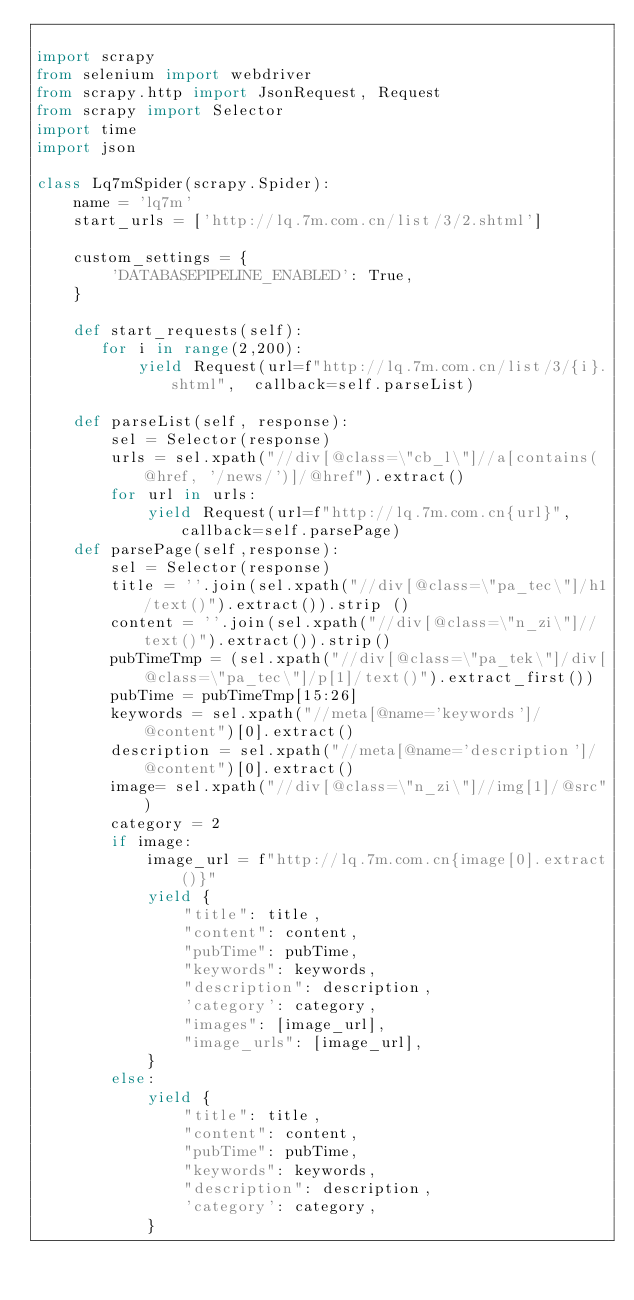<code> <loc_0><loc_0><loc_500><loc_500><_Python_>
import scrapy
from selenium import webdriver
from scrapy.http import JsonRequest, Request
from scrapy import Selector
import time
import json

class Lq7mSpider(scrapy.Spider):
    name = 'lq7m'
    start_urls = ['http://lq.7m.com.cn/list/3/2.shtml']

    custom_settings = {
        'DATABASEPIPELINE_ENABLED': True,
    }

    def start_requests(self):
       for i in range(2,200):
           yield Request(url=f"http://lq.7m.com.cn/list/3/{i}.shtml",  callback=self.parseList)

    def parseList(self, response):
        sel = Selector(response)
        urls = sel.xpath("//div[@class=\"cb_l\"]//a[contains(@href, '/news/')]/@href").extract()
        for url in urls:
            yield Request(url=f"http://lq.7m.com.cn{url}",callback=self.parsePage)
    def parsePage(self,response):
        sel = Selector(response)
        title = ''.join(sel.xpath("//div[@class=\"pa_tec\"]/h1/text()").extract()).strip ()
        content = ''.join(sel.xpath("//div[@class=\"n_zi\"]//text()").extract()).strip()
        pubTimeTmp = (sel.xpath("//div[@class=\"pa_tek\"]/div[@class=\"pa_tec\"]/p[1]/text()").extract_first())
        pubTime = pubTimeTmp[15:26] 
        keywords = sel.xpath("//meta[@name='keywords']/@content")[0].extract()
        description = sel.xpath("//meta[@name='description']/@content")[0].extract()
        image= sel.xpath("//div[@class=\"n_zi\"]//img[1]/@src")
        category = 2
        if image:
            image_url = f"http://lq.7m.com.cn{image[0].extract()}"
            yield {
                "title": title,
                "content": content,
                "pubTime": pubTime,
                "keywords": keywords,
                "description": description,
                'category': category,
                "images": [image_url],
                "image_urls": [image_url],
            }
        else:
            yield {
                "title": title,
                "content": content,
                "pubTime": pubTime,
                "keywords": keywords,
                "description": description,
                'category': category,
            }
</code> 